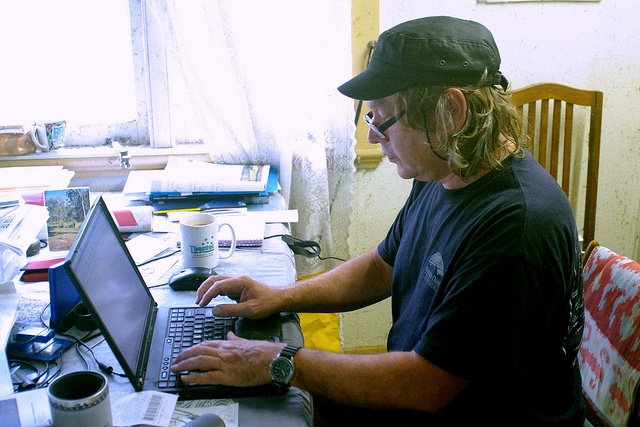Describe the objects in this image and their specific colors. I can see people in white, black, gray, olive, and maroon tones, laptop in white, black, gray, and darkgray tones, chair in white, maroon, gray, and black tones, chair in white, olive, and tan tones, and book in white, lavender, and darkgray tones in this image. 